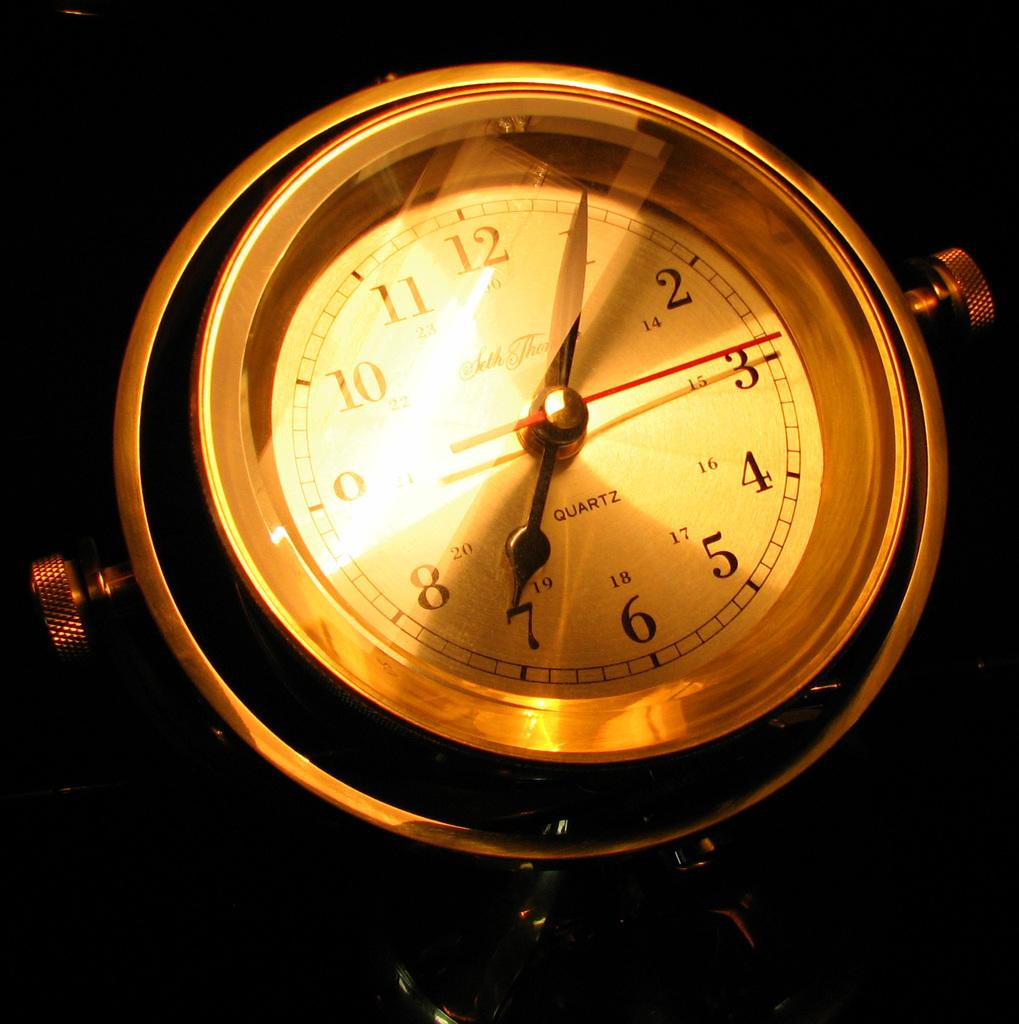<image>
Describe the image concisely. A gold quartz watch shows a time of 7:05 and fifteen seconds. 